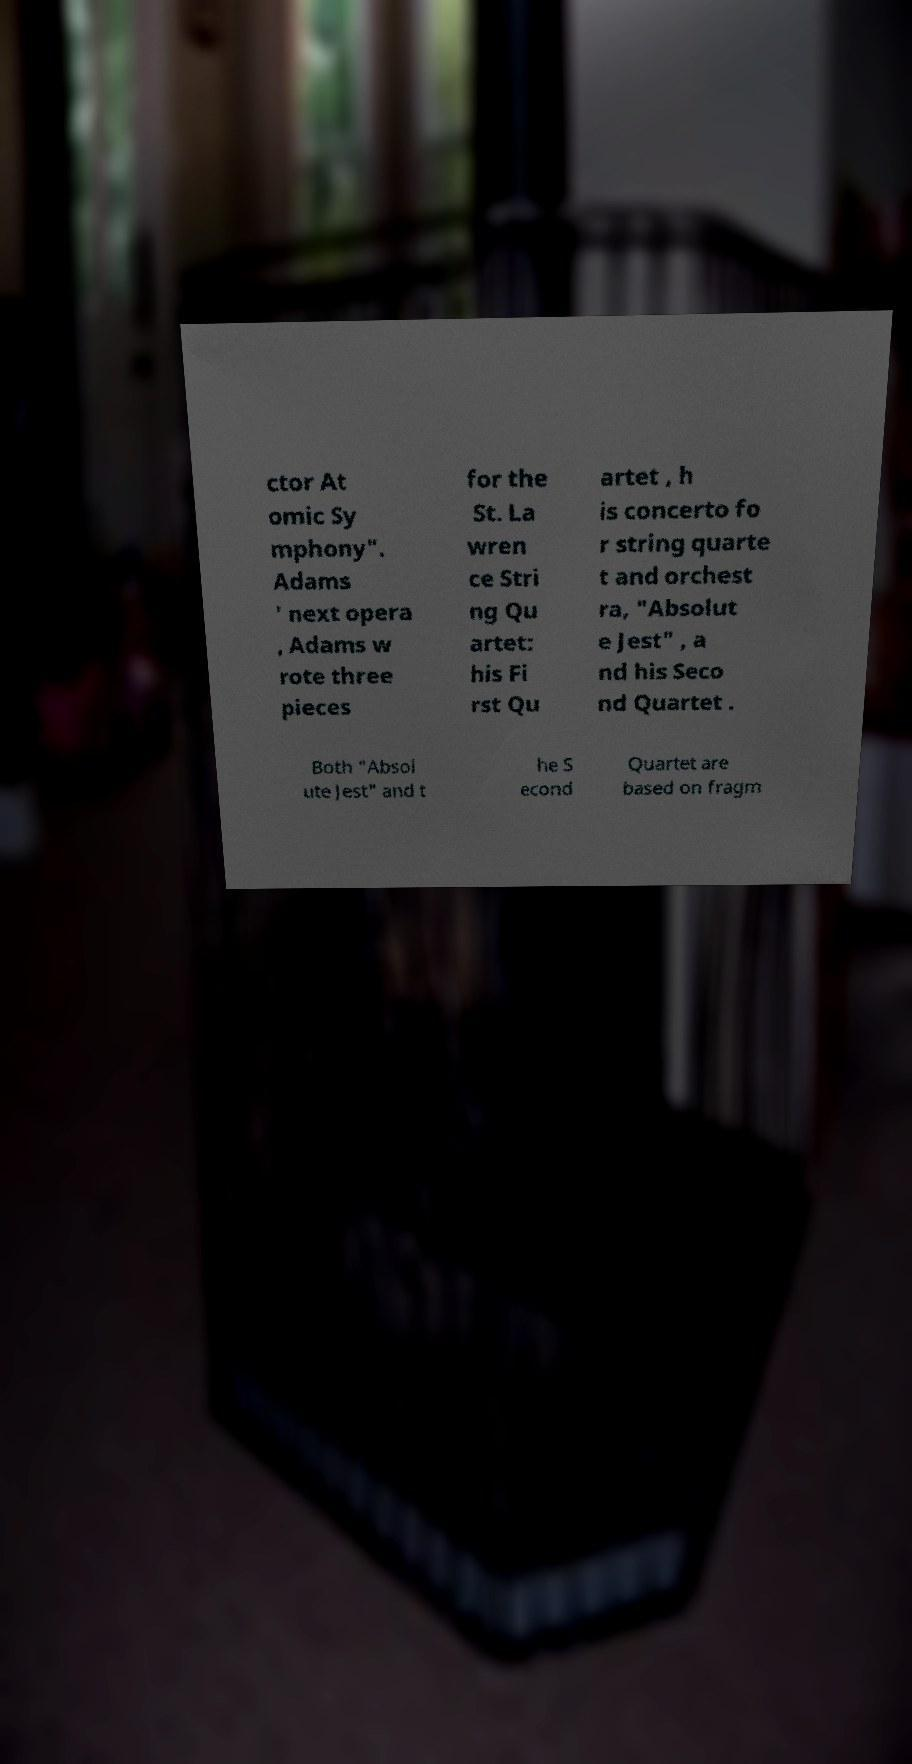Could you extract and type out the text from this image? ctor At omic Sy mphony". Adams ' next opera , Adams w rote three pieces for the St. La wren ce Stri ng Qu artet: his Fi rst Qu artet , h is concerto fo r string quarte t and orchest ra, "Absolut e Jest" , a nd his Seco nd Quartet . Both "Absol ute Jest" and t he S econd Quartet are based on fragm 